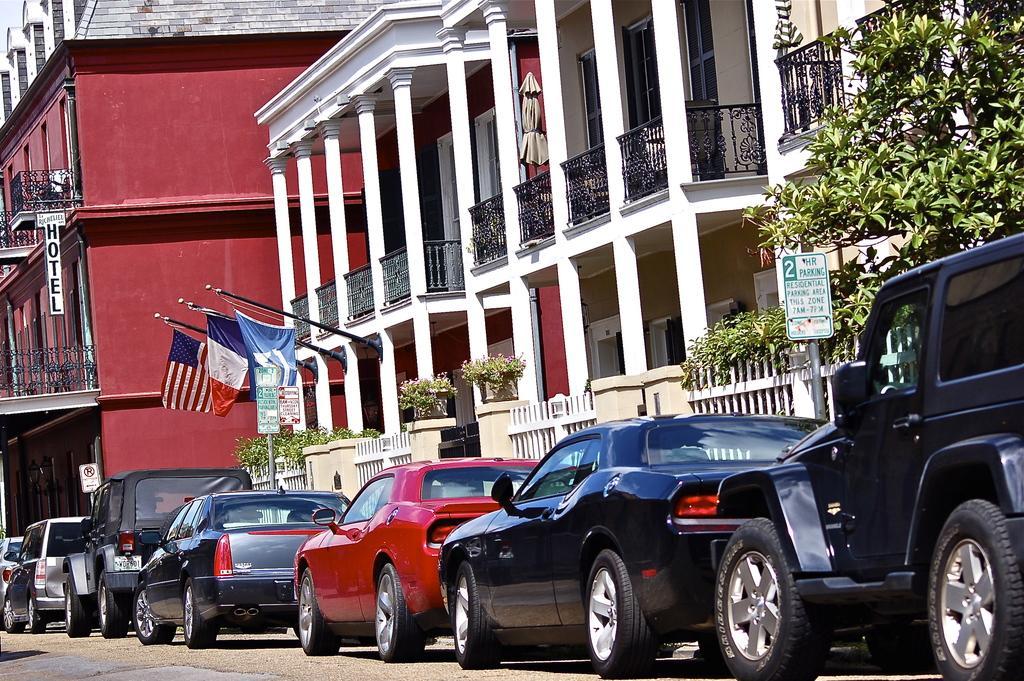Describe this image in one or two sentences. In this image there are some buildings, trees and in the center there are some vehicles on the road. And also there are some poles and flags on the right side there is one pole and board, on the board there is some text. At the bottom there is road. 